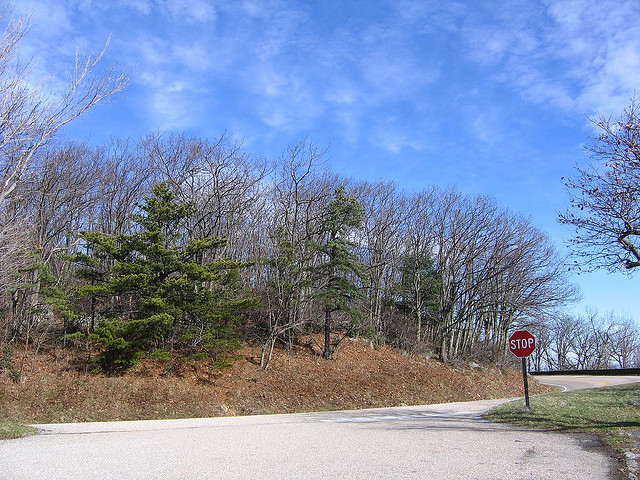Is the path paved? Yes, the path shown in the image is paved, as seen by the smooth asphalt surface of the road. 